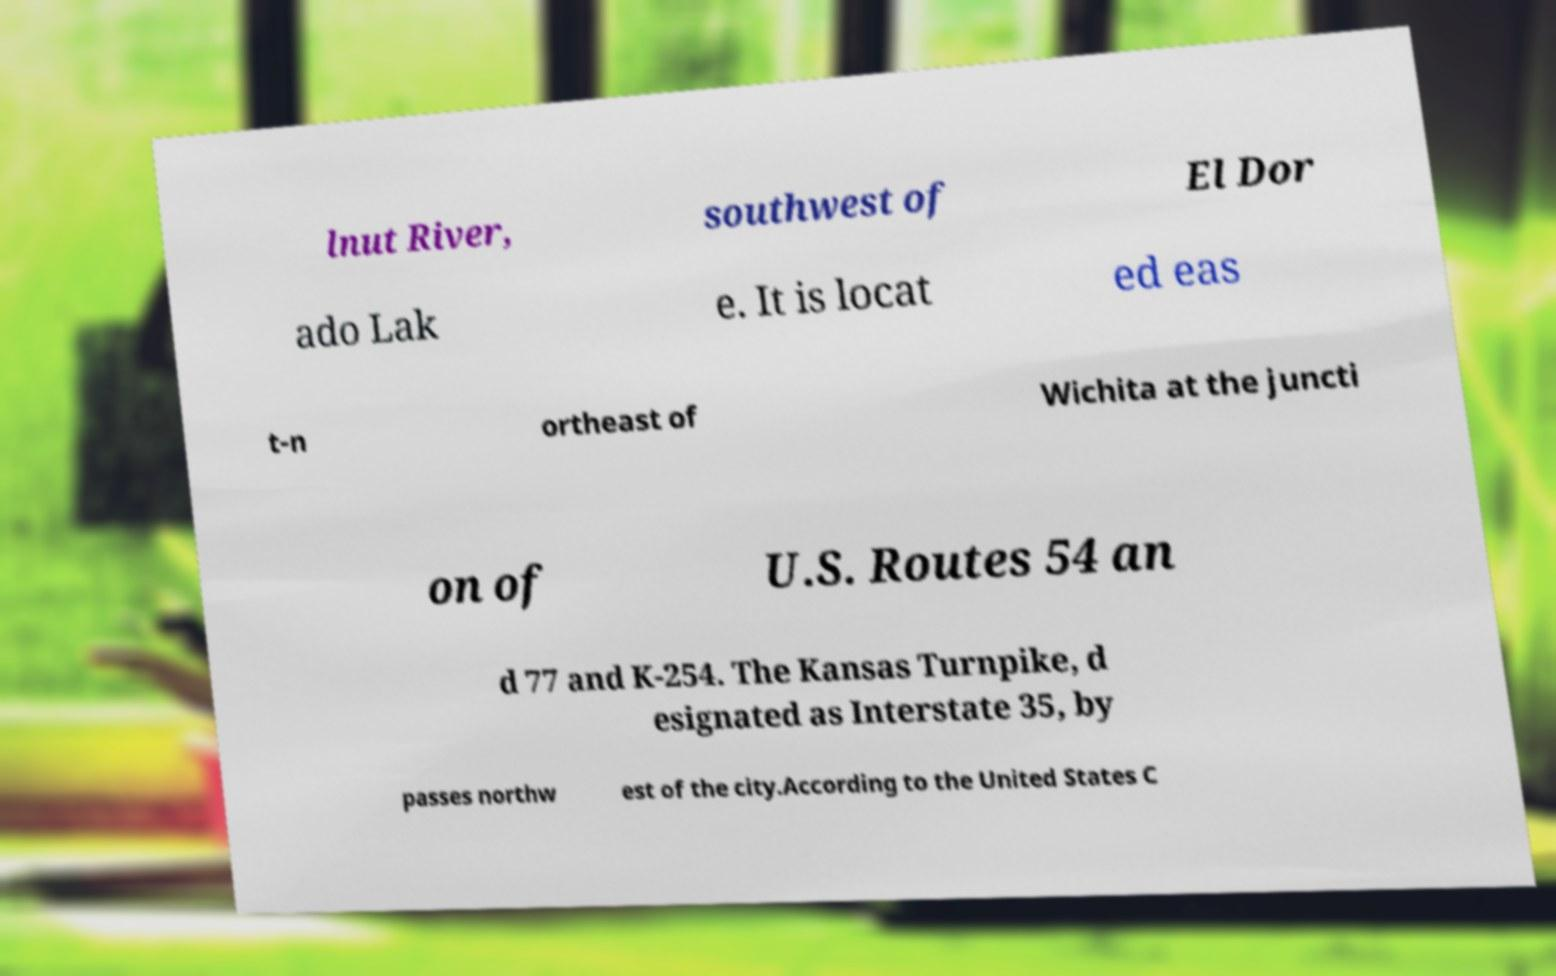Please identify and transcribe the text found in this image. lnut River, southwest of El Dor ado Lak e. It is locat ed eas t-n ortheast of Wichita at the juncti on of U.S. Routes 54 an d 77 and K-254. The Kansas Turnpike, d esignated as Interstate 35, by passes northw est of the city.According to the United States C 